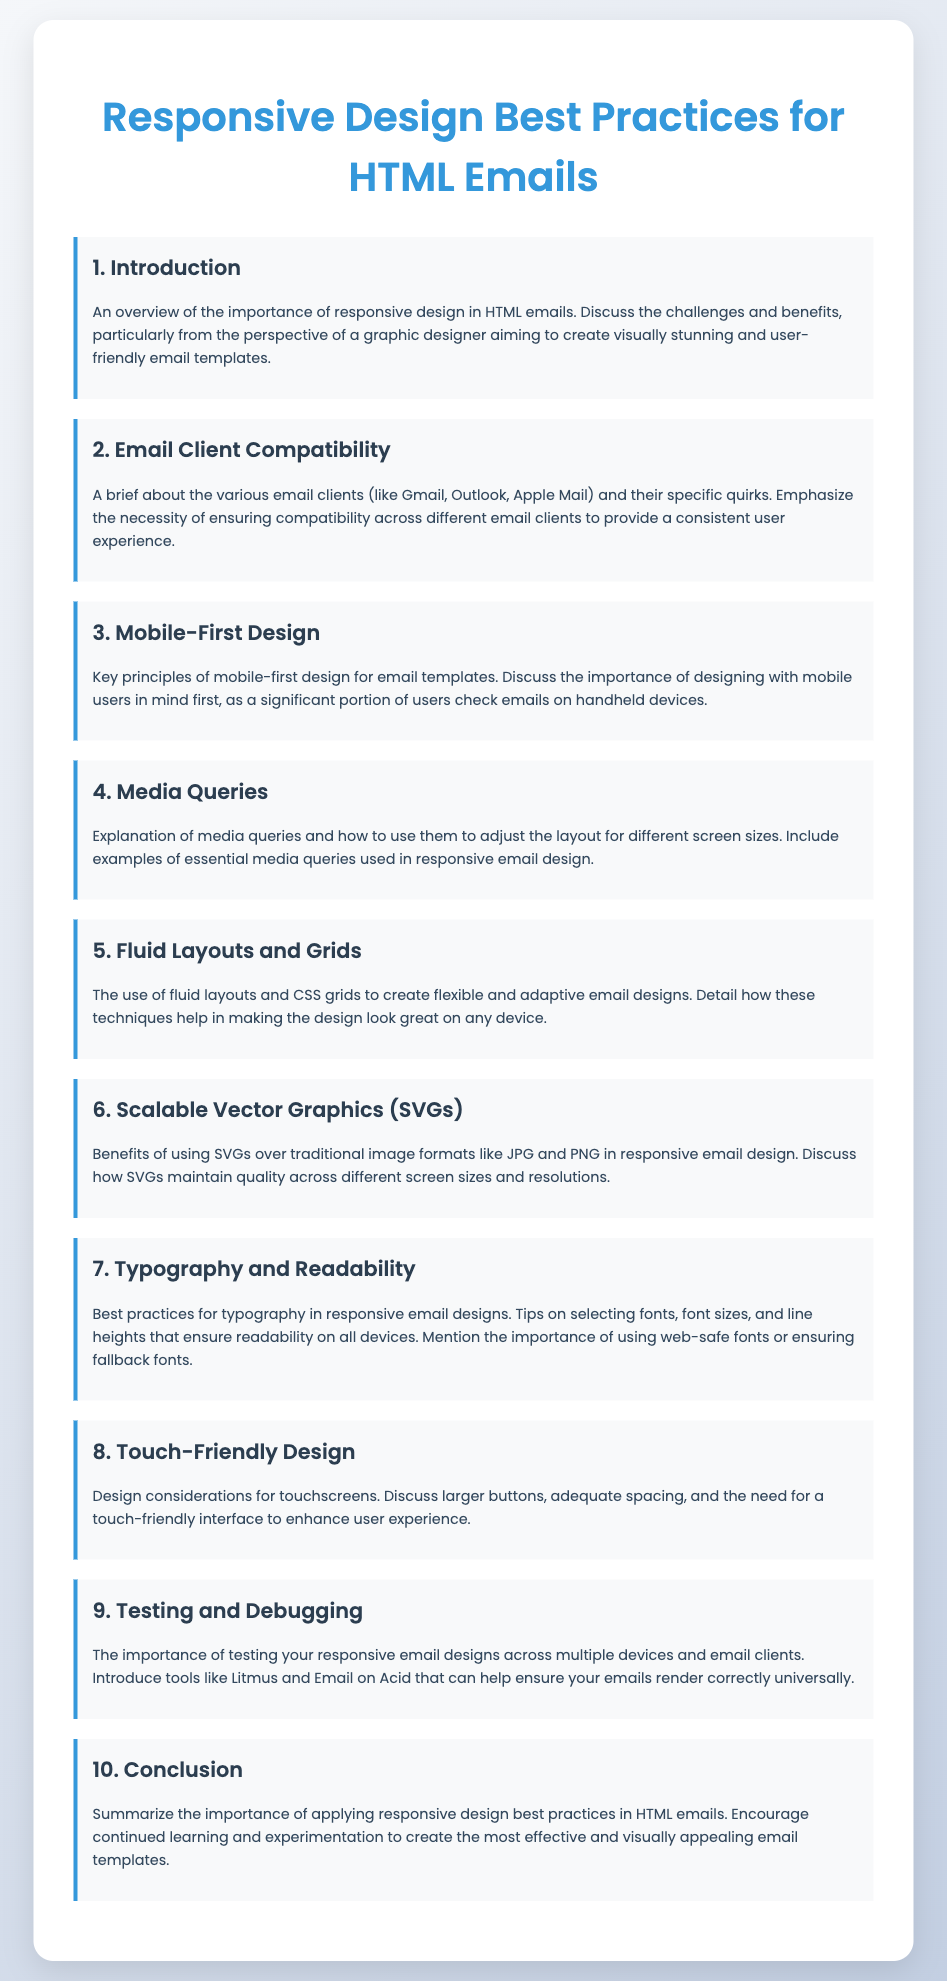What is the title of the document? The title is stated in the head section of the HTML document.
Answer: Responsive Design Best Practices for HTML Emails How many sections are in the document? The document contains a total of ten sections, each indicated by a heading and content.
Answer: 10 What color is used for the main heading? The color of the main heading is specified within the CSS styles associated with the h1 element.
Answer: #3498db What is discussed in the “Media Queries” section? The “Media Queries” section explains how to use media queries to adjust layout for different screen sizes.
Answer: Adjust the layout for different screen sizes Which technique helps in making email designs look great on any device? This question refers to the explanation in the “Fluid Layouts and Grids” section of the document.
Answer: Fluid layouts and CSS grids What should be emphasized for a touch-friendly design? This comes from the section discussing design considerations for touchscreen devices.
Answer: Larger buttons and adequate spacing What do tools like Litmus and Email on Acid help with? These tools are introduced in the “Testing and Debugging” section for their specific purpose.
Answer: Ensure emails render correctly universally 